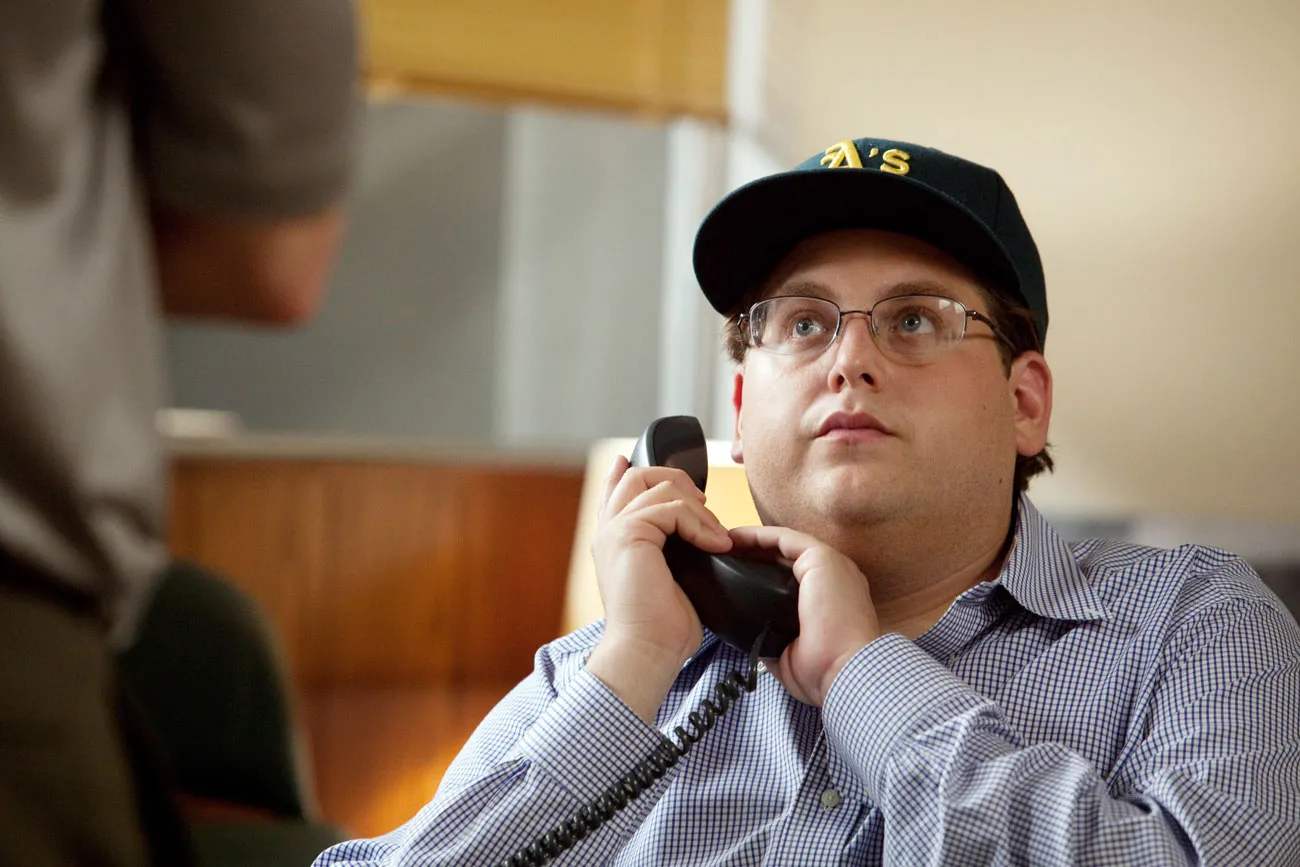Describe the following image. This image features a man in an office environment engaged in a phone conversation. He appears thoughtful or focused, perhaps dealing with a complex issue. The man is dressed in a blue and white striped shirt and sports a green cap, which suggests a casual office atmosphere or personal style. The background is softly blurred, indicating the photo focuses on his expression and the phone call. 